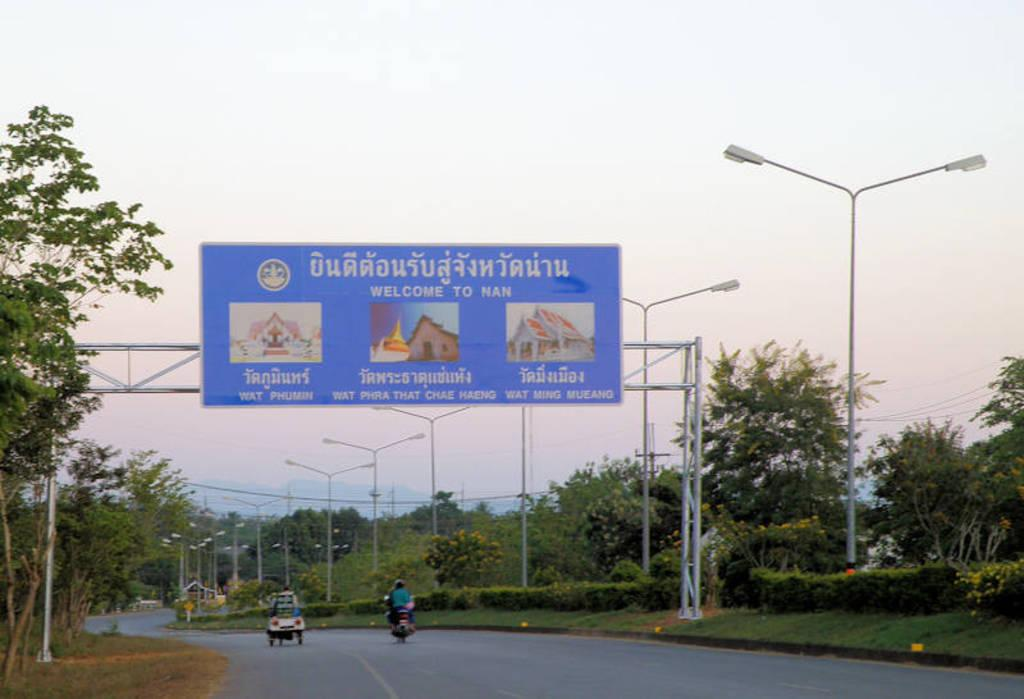<image>
Give a short and clear explanation of the subsequent image. A Welcome to Nan sign over the roadway 